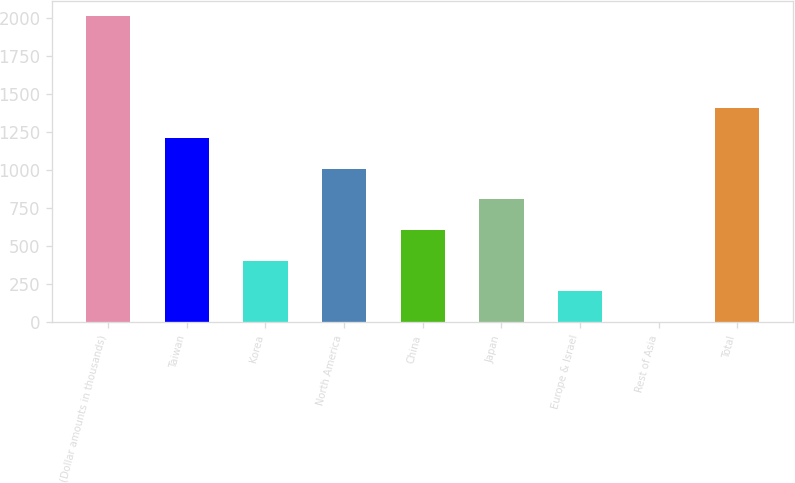Convert chart to OTSL. <chart><loc_0><loc_0><loc_500><loc_500><bar_chart><fcel>(Dollar amounts in thousands)<fcel>Taiwan<fcel>Korea<fcel>North America<fcel>China<fcel>Japan<fcel>Europe & Israel<fcel>Rest of Asia<fcel>Total<nl><fcel>2016<fcel>1211.6<fcel>407.2<fcel>1010.5<fcel>608.3<fcel>809.4<fcel>206.1<fcel>5<fcel>1412.7<nl></chart> 